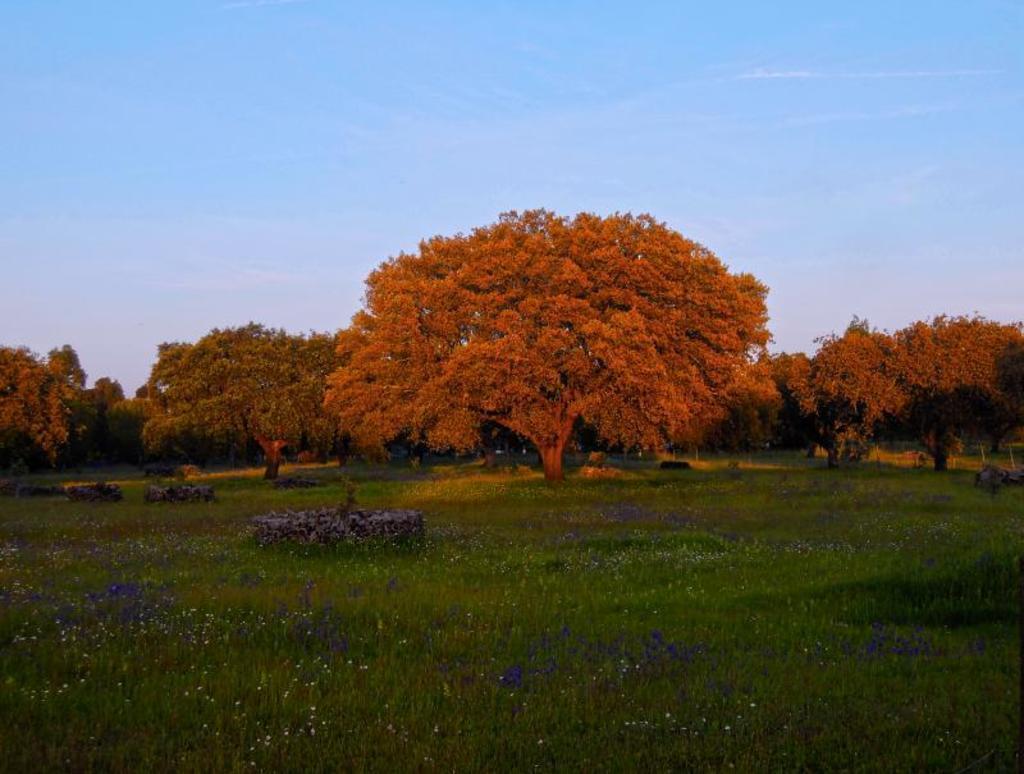Can you describe this image briefly? There are plenty of big trees in a garden and around the trees there are small plants with some flowers. 